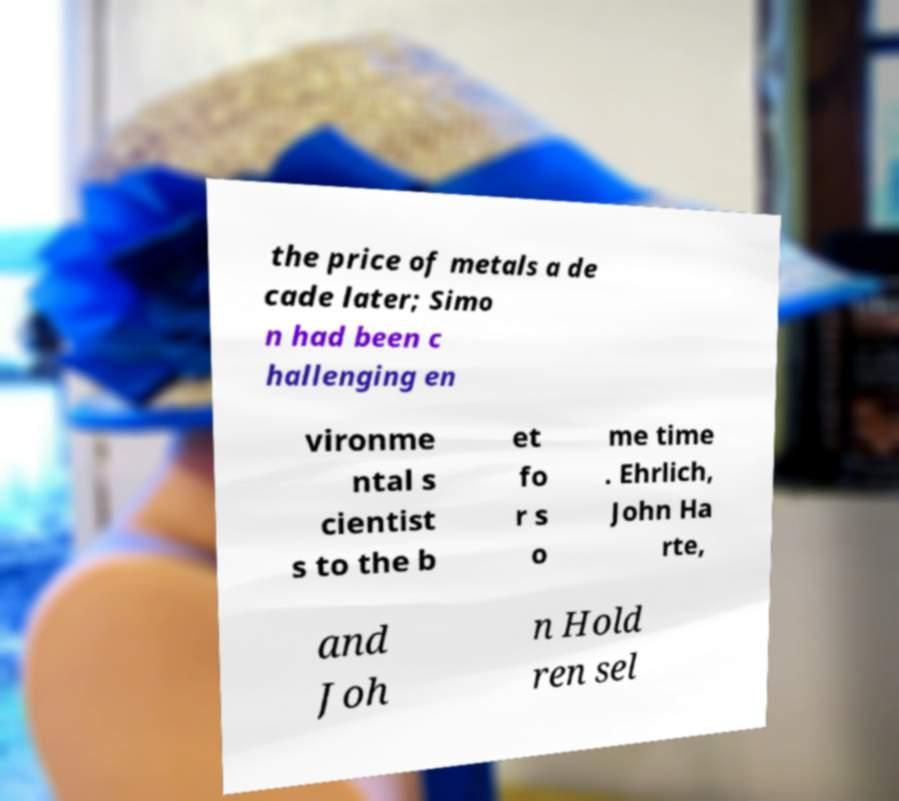I need the written content from this picture converted into text. Can you do that? the price of metals a de cade later; Simo n had been c hallenging en vironme ntal s cientist s to the b et fo r s o me time . Ehrlich, John Ha rte, and Joh n Hold ren sel 